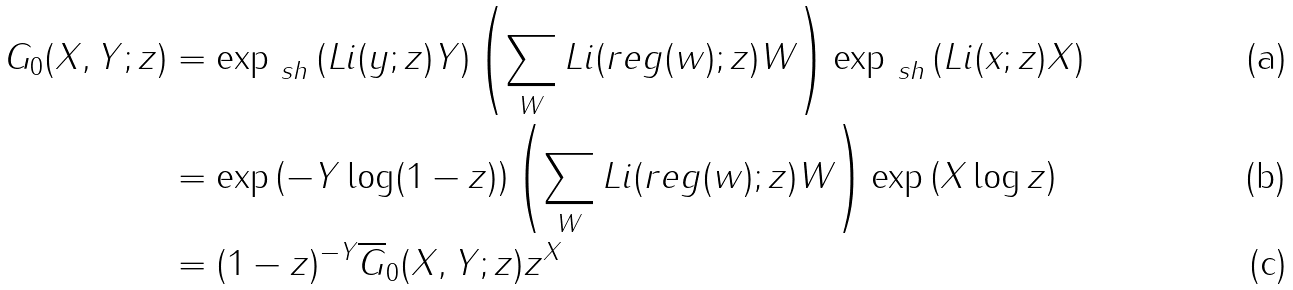Convert formula to latex. <formula><loc_0><loc_0><loc_500><loc_500>G _ { 0 } ( X , Y ; z ) & = \exp _ { \ s h } \left ( L i ( y ; z ) Y \right ) \left ( \sum _ { W } L i ( r e g ( w ) ; z ) W \right ) \exp _ { \ s h } \left ( L i ( x ; z ) X \right ) \\ & = \exp \left ( - Y \log ( 1 - z ) \right ) \left ( \sum _ { W } L i ( r e g ( w ) ; z ) W \right ) \exp \left ( X \log z \right ) \\ & = ( 1 - z ) ^ { - Y } \overline { G } _ { 0 } ( X , Y ; z ) z ^ { X }</formula> 